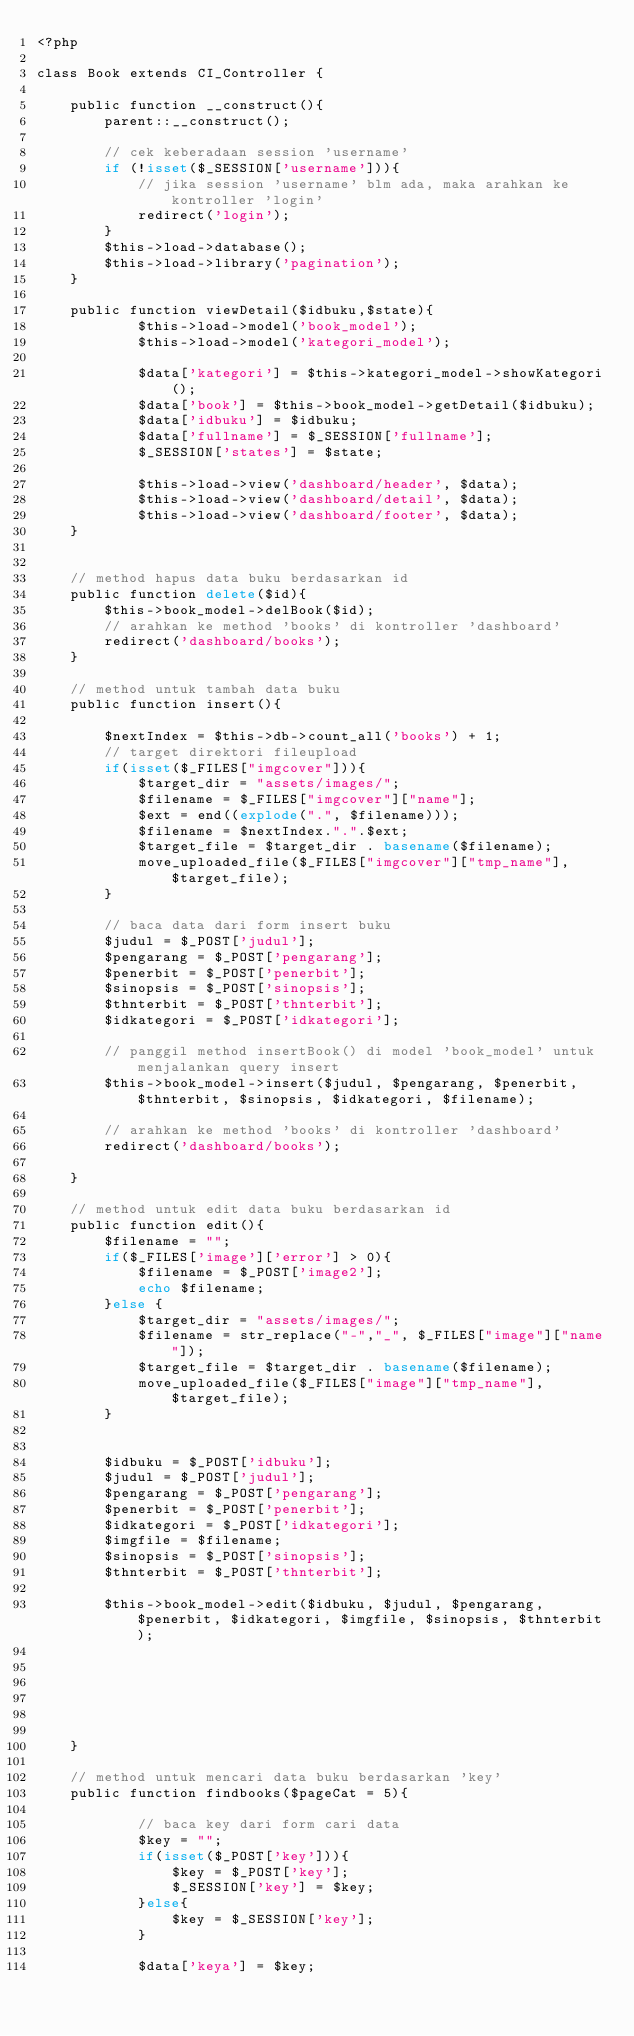Convert code to text. <code><loc_0><loc_0><loc_500><loc_500><_PHP_><?php

class Book extends CI_Controller {

	public function __construct(){
		parent::__construct();
		
		// cek keberadaan session 'username'	
		if (!isset($_SESSION['username'])){
			// jika session 'username' blm ada, maka arahkan ke kontroller 'login'
			redirect('login');
		}
		$this->load->database();
		$this->load->library('pagination');
	}

	public function viewDetail($idbuku,$state){
            $this->load->model('book_model');
            $this->load->model('kategori_model');

			$data['kategori'] = $this->kategori_model->showKategori();
            $data['book'] = $this->book_model->getDetail($idbuku);
            $data['idbuku'] = $idbuku;
            $data['fullname'] = $_SESSION['fullname'];
            $_SESSION['states'] = $state;

            $this->load->view('dashboard/header', $data);
            $this->load->view('dashboard/detail', $data);
            $this->load->view('dashboard/footer', $data);
    }


	// method hapus data buku berdasarkan id
	public function delete($id){
		$this->book_model->delBook($id);
		// arahkan ke method 'books' di kontroller 'dashboard'
		redirect('dashboard/books');
	}

	// method untuk tambah data buku
	public function insert(){
		
        $nextIndex = $this->db->count_all('books') + 1;
		// target direktori fileupload
		if(isset($_FILES["imgcover"])){
			$target_dir = "assets/images/";
			$filename = $_FILES["imgcover"]["name"];
			$ext = end((explode(".", $filename))); 
			$filename = $nextIndex.".".$ext;
			$target_file = $target_dir . basename($filename);
			move_uploaded_file($_FILES["imgcover"]["tmp_name"], $target_file);
		}
		
		// baca data dari form insert buku
		$judul = $_POST['judul'];
		$pengarang = $_POST['pengarang'];
		$penerbit = $_POST['penerbit'];
		$sinopsis = $_POST['sinopsis'];
		$thnterbit = $_POST['thnterbit'];
		$idkategori = $_POST['idkategori'];

		// panggil method insertBook() di model 'book_model' untuk menjalankan query insert
		$this->book_model->insert($judul, $pengarang, $penerbit, $thnterbit, $sinopsis, $idkategori, $filename);

		// arahkan ke method 'books' di kontroller 'dashboard'
		redirect('dashboard/books');
		
	}

	// method untuk edit data buku berdasarkan id
	public function edit(){
		$filename = "";
		if($_FILES['image']['error'] > 0){
			$filename = $_POST['image2'];
			echo $filename;
		}else {
			$target_dir = "assets/images/";
			$filename = str_replace("-","_", $_FILES["image"]["name"]);
			$target_file = $target_dir . basename($filename);
			move_uploaded_file($_FILES["image"]["tmp_name"], $target_file);
		}

		
		$idbuku = $_POST['idbuku'];
        $judul = $_POST['judul'];
        $pengarang = $_POST['pengarang'];
        $penerbit = $_POST['penerbit'];
        $idkategori = $_POST['idkategori'];
        $imgfile = $filename;
        $sinopsis = $_POST['sinopsis'];
        $thnterbit = $_POST['thnterbit'];

        $this->book_model->edit($idbuku, $judul, $pengarang, $penerbit, $idkategori, $imgfile, $sinopsis, $thnterbit);	
			
			

				
    	

	}

	// method untuk mencari data buku berdasarkan 'key'
	public function findbooks($pageCat = 5){
		
			// baca key dari form cari data
			$key = "";
			if(isset($_POST['key'])){
				$key = $_POST['key'];
				$_SESSION['key'] = $key;
			}else{
				$key = $_SESSION['key'];
			}

			$data['keya'] = $key;
</code> 